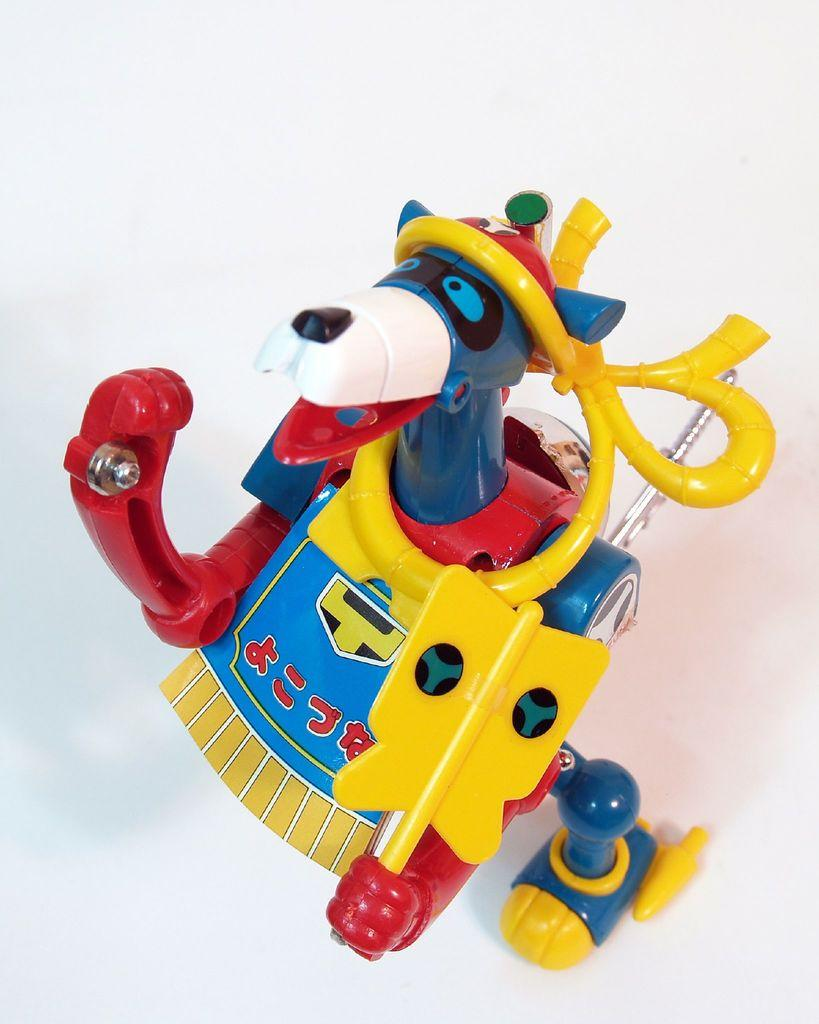What is the main object in the foreground of the image? There is a toy in the foreground of the image. What is the color of the surface on which the toy is placed? The toy is on a white surface. How many eggs are visible in the image? There are no eggs present in the image. What shape is the finger in the image? There is no finger present in the image. 